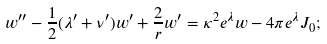<formula> <loc_0><loc_0><loc_500><loc_500>w ^ { \prime \prime } - \frac { 1 } { 2 } ( \lambda ^ { \prime } + \nu ^ { \prime } ) w ^ { \prime } + \frac { 2 } { r } w ^ { \prime } = \kappa ^ { 2 } e ^ { \lambda } w - 4 \pi e ^ { \lambda } J _ { 0 } ;</formula> 